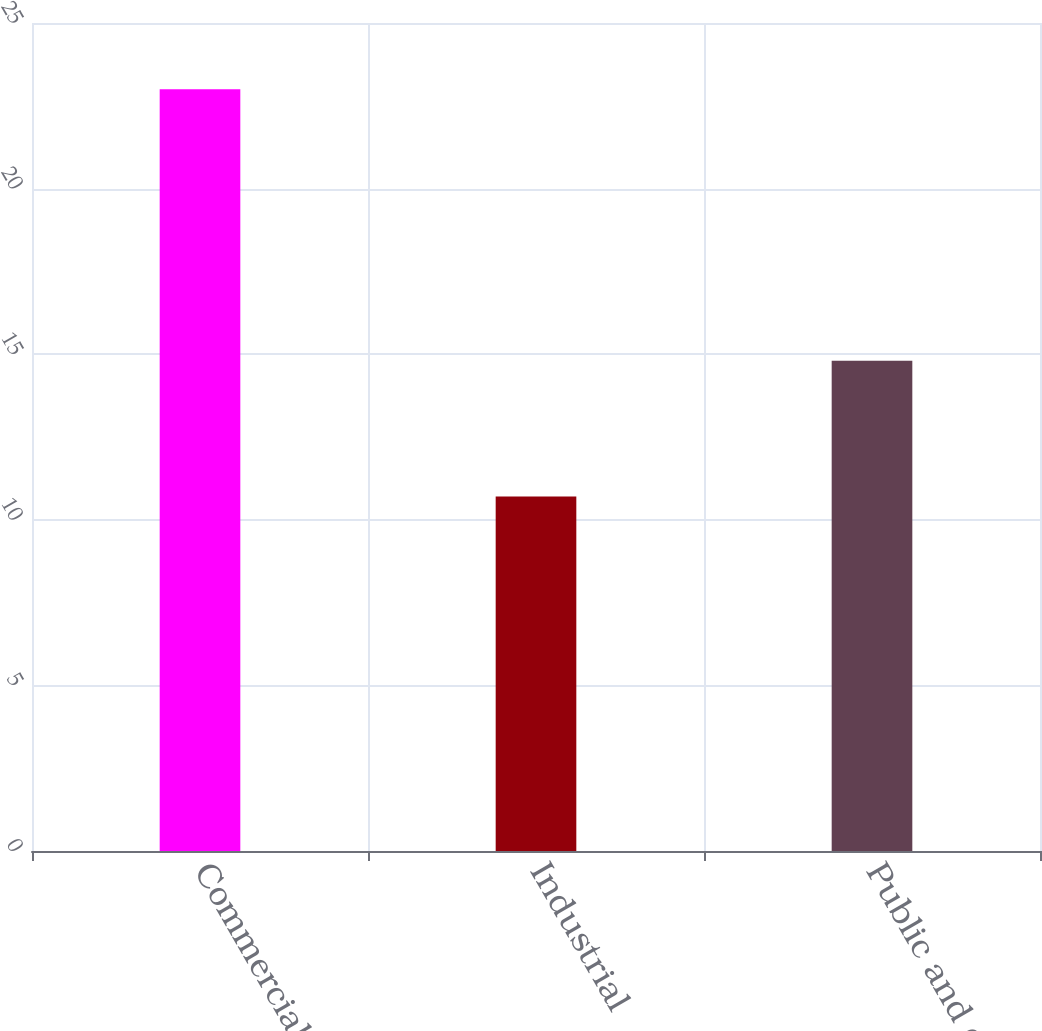Convert chart. <chart><loc_0><loc_0><loc_500><loc_500><bar_chart><fcel>Commercial<fcel>Industrial<fcel>Public and other<nl><fcel>23<fcel>10.7<fcel>14.8<nl></chart> 